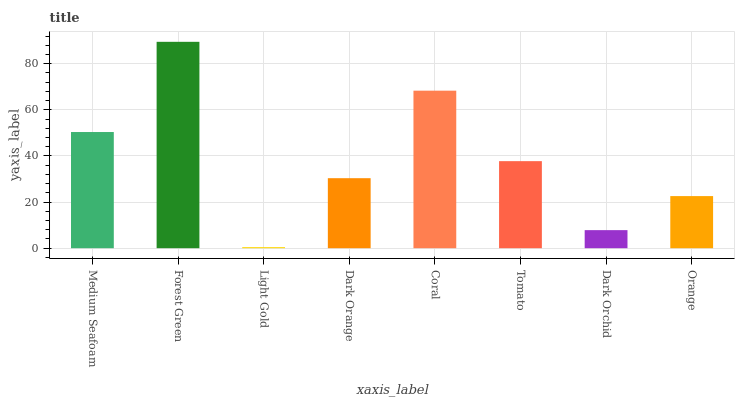Is Light Gold the minimum?
Answer yes or no. Yes. Is Forest Green the maximum?
Answer yes or no. Yes. Is Forest Green the minimum?
Answer yes or no. No. Is Light Gold the maximum?
Answer yes or no. No. Is Forest Green greater than Light Gold?
Answer yes or no. Yes. Is Light Gold less than Forest Green?
Answer yes or no. Yes. Is Light Gold greater than Forest Green?
Answer yes or no. No. Is Forest Green less than Light Gold?
Answer yes or no. No. Is Tomato the high median?
Answer yes or no. Yes. Is Dark Orange the low median?
Answer yes or no. Yes. Is Orange the high median?
Answer yes or no. No. Is Coral the low median?
Answer yes or no. No. 